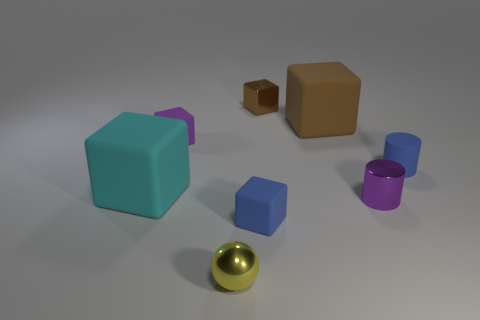Subtract all large cyan blocks. How many blocks are left? 4 Subtract all blue blocks. How many blocks are left? 4 Add 1 tiny purple shiny things. How many objects exist? 9 Subtract all cylinders. How many objects are left? 6 Add 7 tiny green spheres. How many tiny green spheres exist? 7 Subtract 0 yellow cylinders. How many objects are left? 8 Subtract 3 blocks. How many blocks are left? 2 Subtract all yellow blocks. Subtract all red cylinders. How many blocks are left? 5 Subtract all red spheres. How many brown blocks are left? 2 Subtract all small shiny balls. Subtract all purple cylinders. How many objects are left? 6 